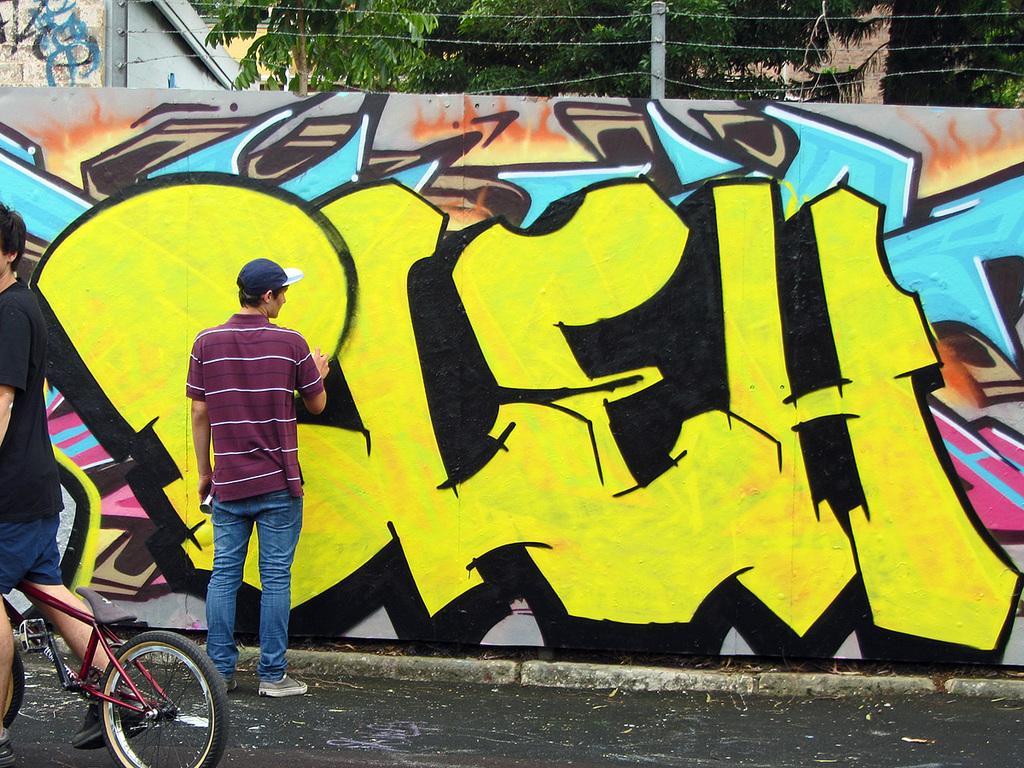Please provide a concise description of this image. In this picture, we see a man maroon t-shirt and blue t-shirt is painting the wall. This picture is clicked outside the city. We can see even a man in black t-shirt is riding bicycle. Behind the wall, we see fence and behind that, we see trees and building. 